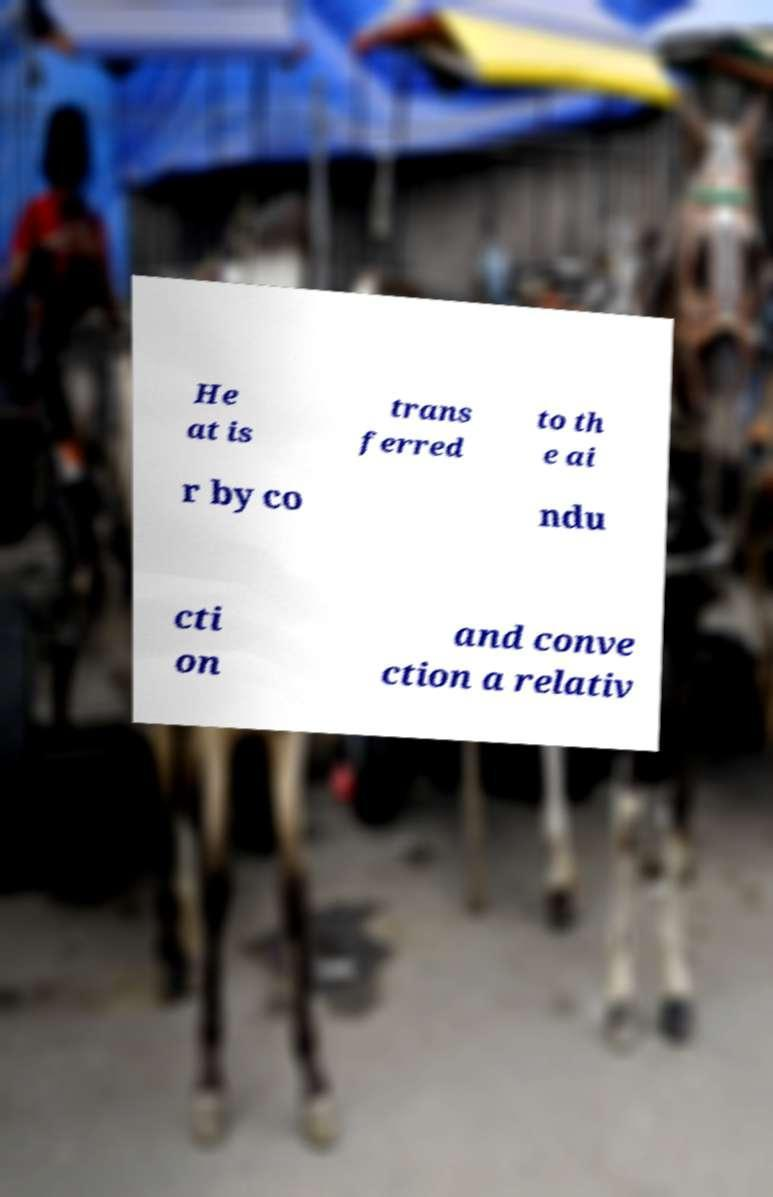Could you assist in decoding the text presented in this image and type it out clearly? He at is trans ferred to th e ai r by co ndu cti on and conve ction a relativ 